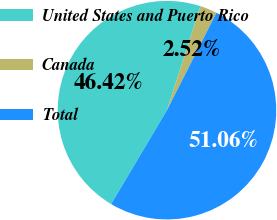Convert chart to OTSL. <chart><loc_0><loc_0><loc_500><loc_500><pie_chart><fcel>United States and Puerto Rico<fcel>Canada<fcel>Total<nl><fcel>46.42%<fcel>2.52%<fcel>51.06%<nl></chart> 